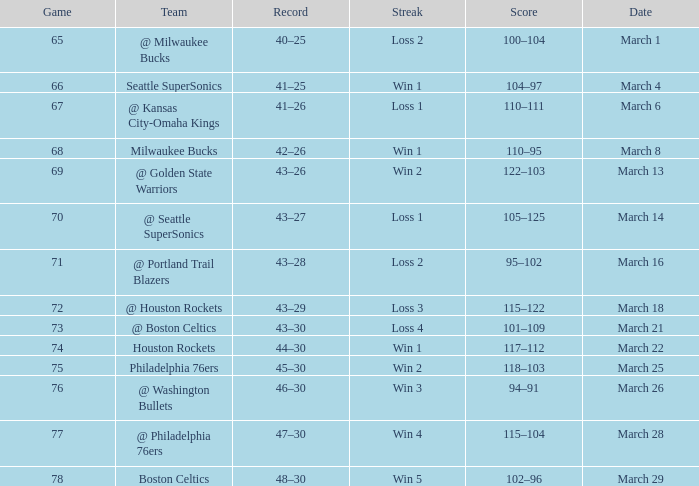Parse the table in full. {'header': ['Game', 'Team', 'Record', 'Streak', 'Score', 'Date'], 'rows': [['65', '@ Milwaukee Bucks', '40–25', 'Loss 2', '100–104', 'March 1'], ['66', 'Seattle SuperSonics', '41–25', 'Win 1', '104–97', 'March 4'], ['67', '@ Kansas City-Omaha Kings', '41–26', 'Loss 1', '110–111', 'March 6'], ['68', 'Milwaukee Bucks', '42–26', 'Win 1', '110–95', 'March 8'], ['69', '@ Golden State Warriors', '43–26', 'Win 2', '122–103', 'March 13'], ['70', '@ Seattle SuperSonics', '43–27', 'Loss 1', '105–125', 'March 14'], ['71', '@ Portland Trail Blazers', '43–28', 'Loss 2', '95–102', 'March 16'], ['72', '@ Houston Rockets', '43–29', 'Loss 3', '115–122', 'March 18'], ['73', '@ Boston Celtics', '43–30', 'Loss 4', '101–109', 'March 21'], ['74', 'Houston Rockets', '44–30', 'Win 1', '117–112', 'March 22'], ['75', 'Philadelphia 76ers', '45–30', 'Win 2', '118–103', 'March 25'], ['76', '@ Washington Bullets', '46–30', 'Win 3', '94–91', 'March 26'], ['77', '@ Philadelphia 76ers', '47–30', 'Win 4', '115–104', 'March 28'], ['78', 'Boston Celtics', '48–30', 'Win 5', '102–96', 'March 29']]} What is Team, when Game is 73? @ Boston Celtics. 